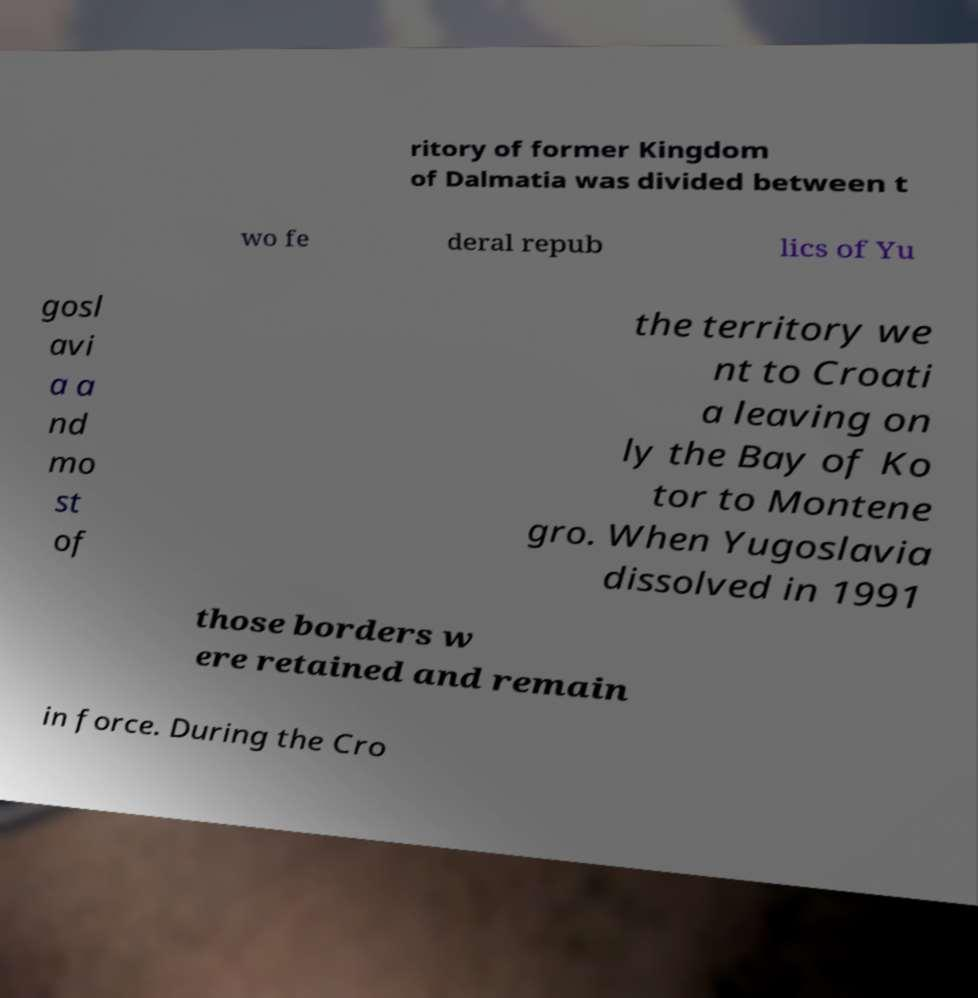Please read and relay the text visible in this image. What does it say? ritory of former Kingdom of Dalmatia was divided between t wo fe deral repub lics of Yu gosl avi a a nd mo st of the territory we nt to Croati a leaving on ly the Bay of Ko tor to Montene gro. When Yugoslavia dissolved in 1991 those borders w ere retained and remain in force. During the Cro 